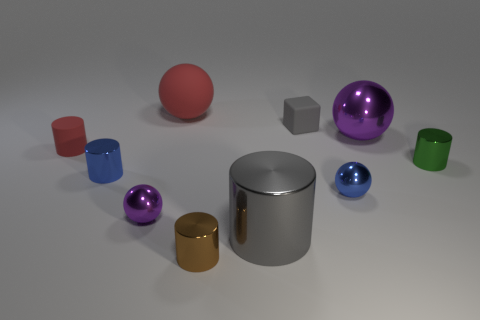Subtract all gray cubes. How many purple spheres are left? 2 Subtract 3 cylinders. How many cylinders are left? 2 Subtract all metal balls. How many balls are left? 1 Subtract all blue cylinders. How many cylinders are left? 4 Subtract all brown cylinders. Subtract all green spheres. How many cylinders are left? 4 Subtract all blocks. How many objects are left? 9 Subtract all tiny yellow metallic cylinders. Subtract all blue things. How many objects are left? 8 Add 2 large purple metal things. How many large purple metal things are left? 3 Add 5 metal balls. How many metal balls exist? 8 Subtract 0 brown spheres. How many objects are left? 10 